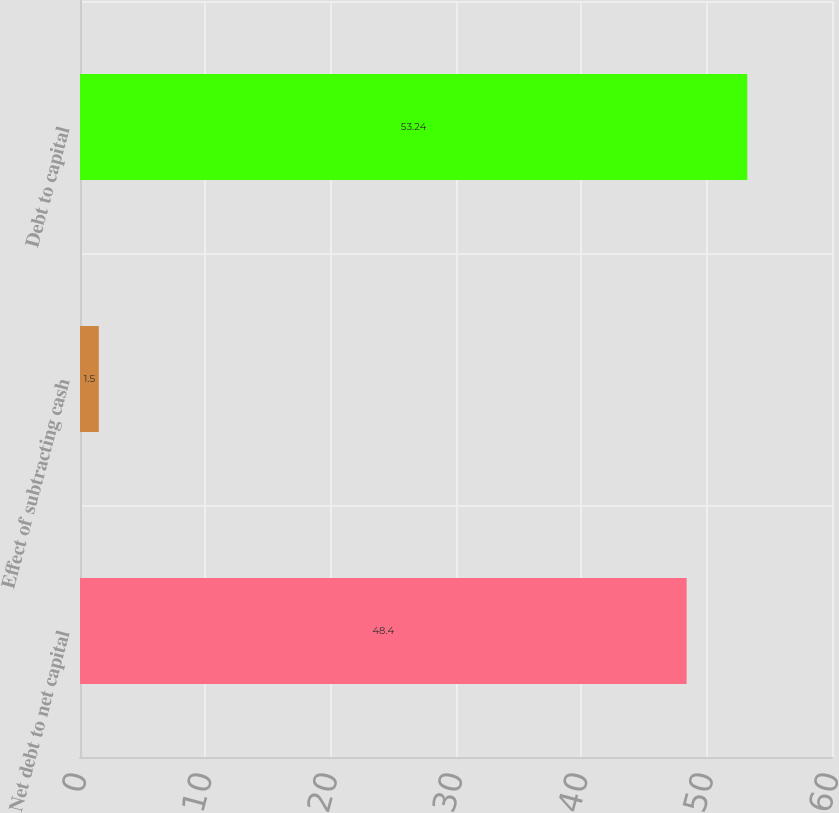Convert chart. <chart><loc_0><loc_0><loc_500><loc_500><bar_chart><fcel>Net debt to net capital<fcel>Effect of subtracting cash<fcel>Debt to capital<nl><fcel>48.4<fcel>1.5<fcel>53.24<nl></chart> 